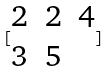<formula> <loc_0><loc_0><loc_500><loc_500>[ \begin{matrix} 2 & 2 & 4 \\ 3 & 5 \end{matrix} ]</formula> 